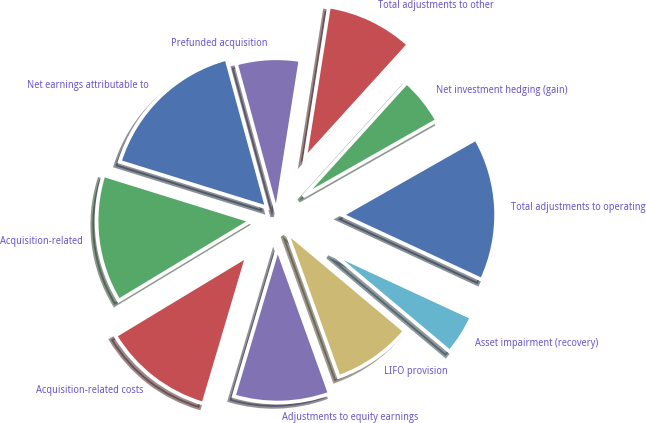Convert chart. <chart><loc_0><loc_0><loc_500><loc_500><pie_chart><fcel>Net earnings attributable to<fcel>Acquisition-related<fcel>Acquisition-related costs<fcel>Adjustments to equity earnings<fcel>LIFO provision<fcel>Asset impairment (recovery)<fcel>Total adjustments to operating<fcel>Net investment hedging (gain)<fcel>Total adjustments to other<fcel>Prefunded acquisition<nl><fcel>15.97%<fcel>13.45%<fcel>11.76%<fcel>10.08%<fcel>8.4%<fcel>4.2%<fcel>15.13%<fcel>5.04%<fcel>9.24%<fcel>6.72%<nl></chart> 